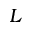Convert formula to latex. <formula><loc_0><loc_0><loc_500><loc_500>L</formula> 